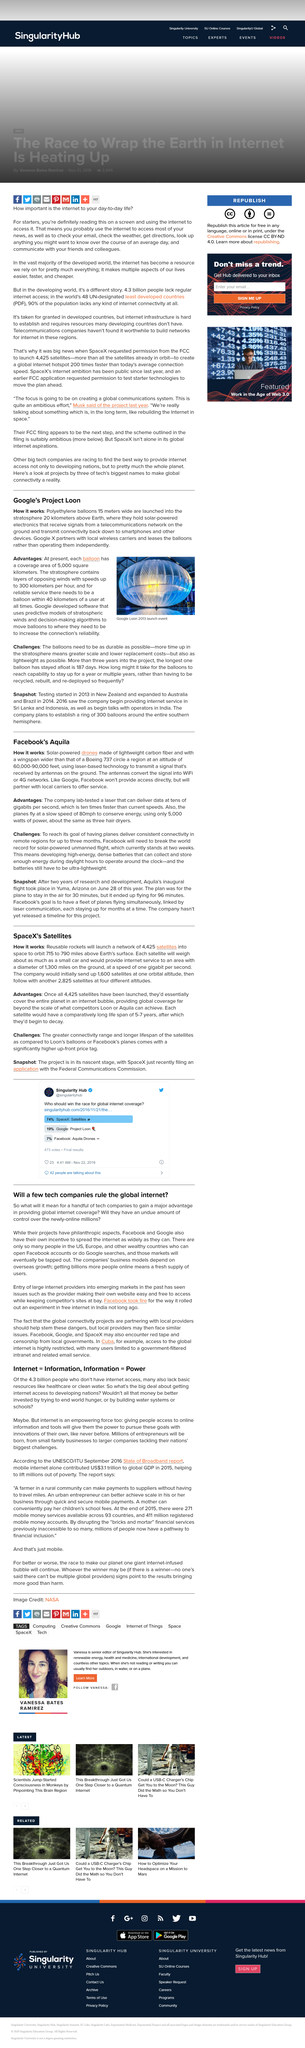List a handful of essential elements in this visual. The image was taken at the Google Loon in 2013. The balloons are made of a material called polyethylene, which is a synthetic polymer made from the chemical reaction of ethylene gas and a catalyst. The coverage area of each balloon is 5000 square kilometers, providing comprehensive and reliable internet connectivity within its vicinity. 